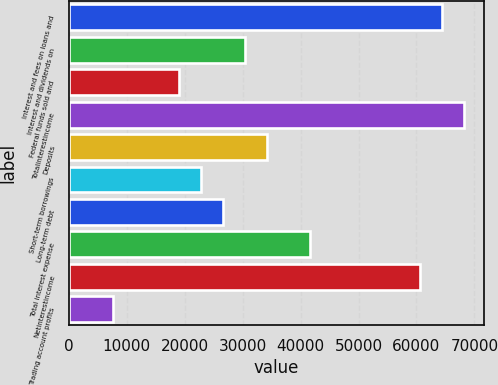Convert chart. <chart><loc_0><loc_0><loc_500><loc_500><bar_chart><fcel>Interest and fees on loans and<fcel>Interest and dividends on<fcel>Federal funds sold and<fcel>Totalinterestincome<fcel>Deposits<fcel>Short-term borrowings<fcel>Long-term debt<fcel>Total interest expense<fcel>Netinterestincome<fcel>Trading account profits<nl><fcel>64451.2<fcel>30331.9<fcel>18958.8<fcel>68242.3<fcel>34122.9<fcel>22749.8<fcel>26540.8<fcel>41705<fcel>60660.2<fcel>7585.65<nl></chart> 